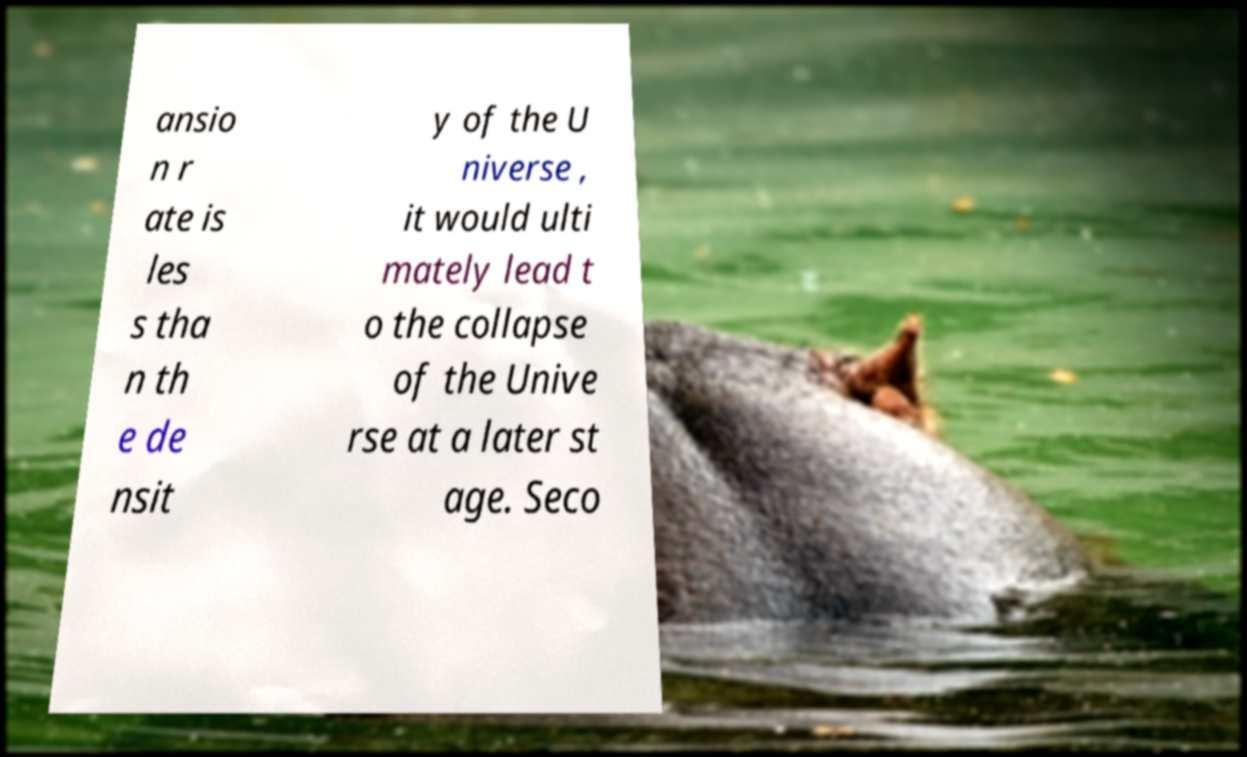There's text embedded in this image that I need extracted. Can you transcribe it verbatim? ansio n r ate is les s tha n th e de nsit y of the U niverse , it would ulti mately lead t o the collapse of the Unive rse at a later st age. Seco 